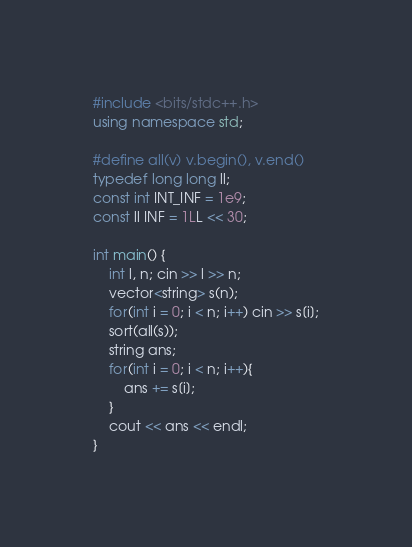<code> <loc_0><loc_0><loc_500><loc_500><_C++_>#include <bits/stdc++.h>
using namespace std;

#define all(v) v.begin(), v.end()
typedef long long ll;
const int INT_INF = 1e9;
const ll INF = 1LL << 30;

int main() {
    int l, n; cin >> l >> n;
    vector<string> s(n);
    for(int i = 0; i < n; i++) cin >> s[i];
    sort(all(s));
    string ans;
    for(int i = 0; i < n; i++){
        ans += s[i];
    }
    cout << ans << endl;
}
</code> 